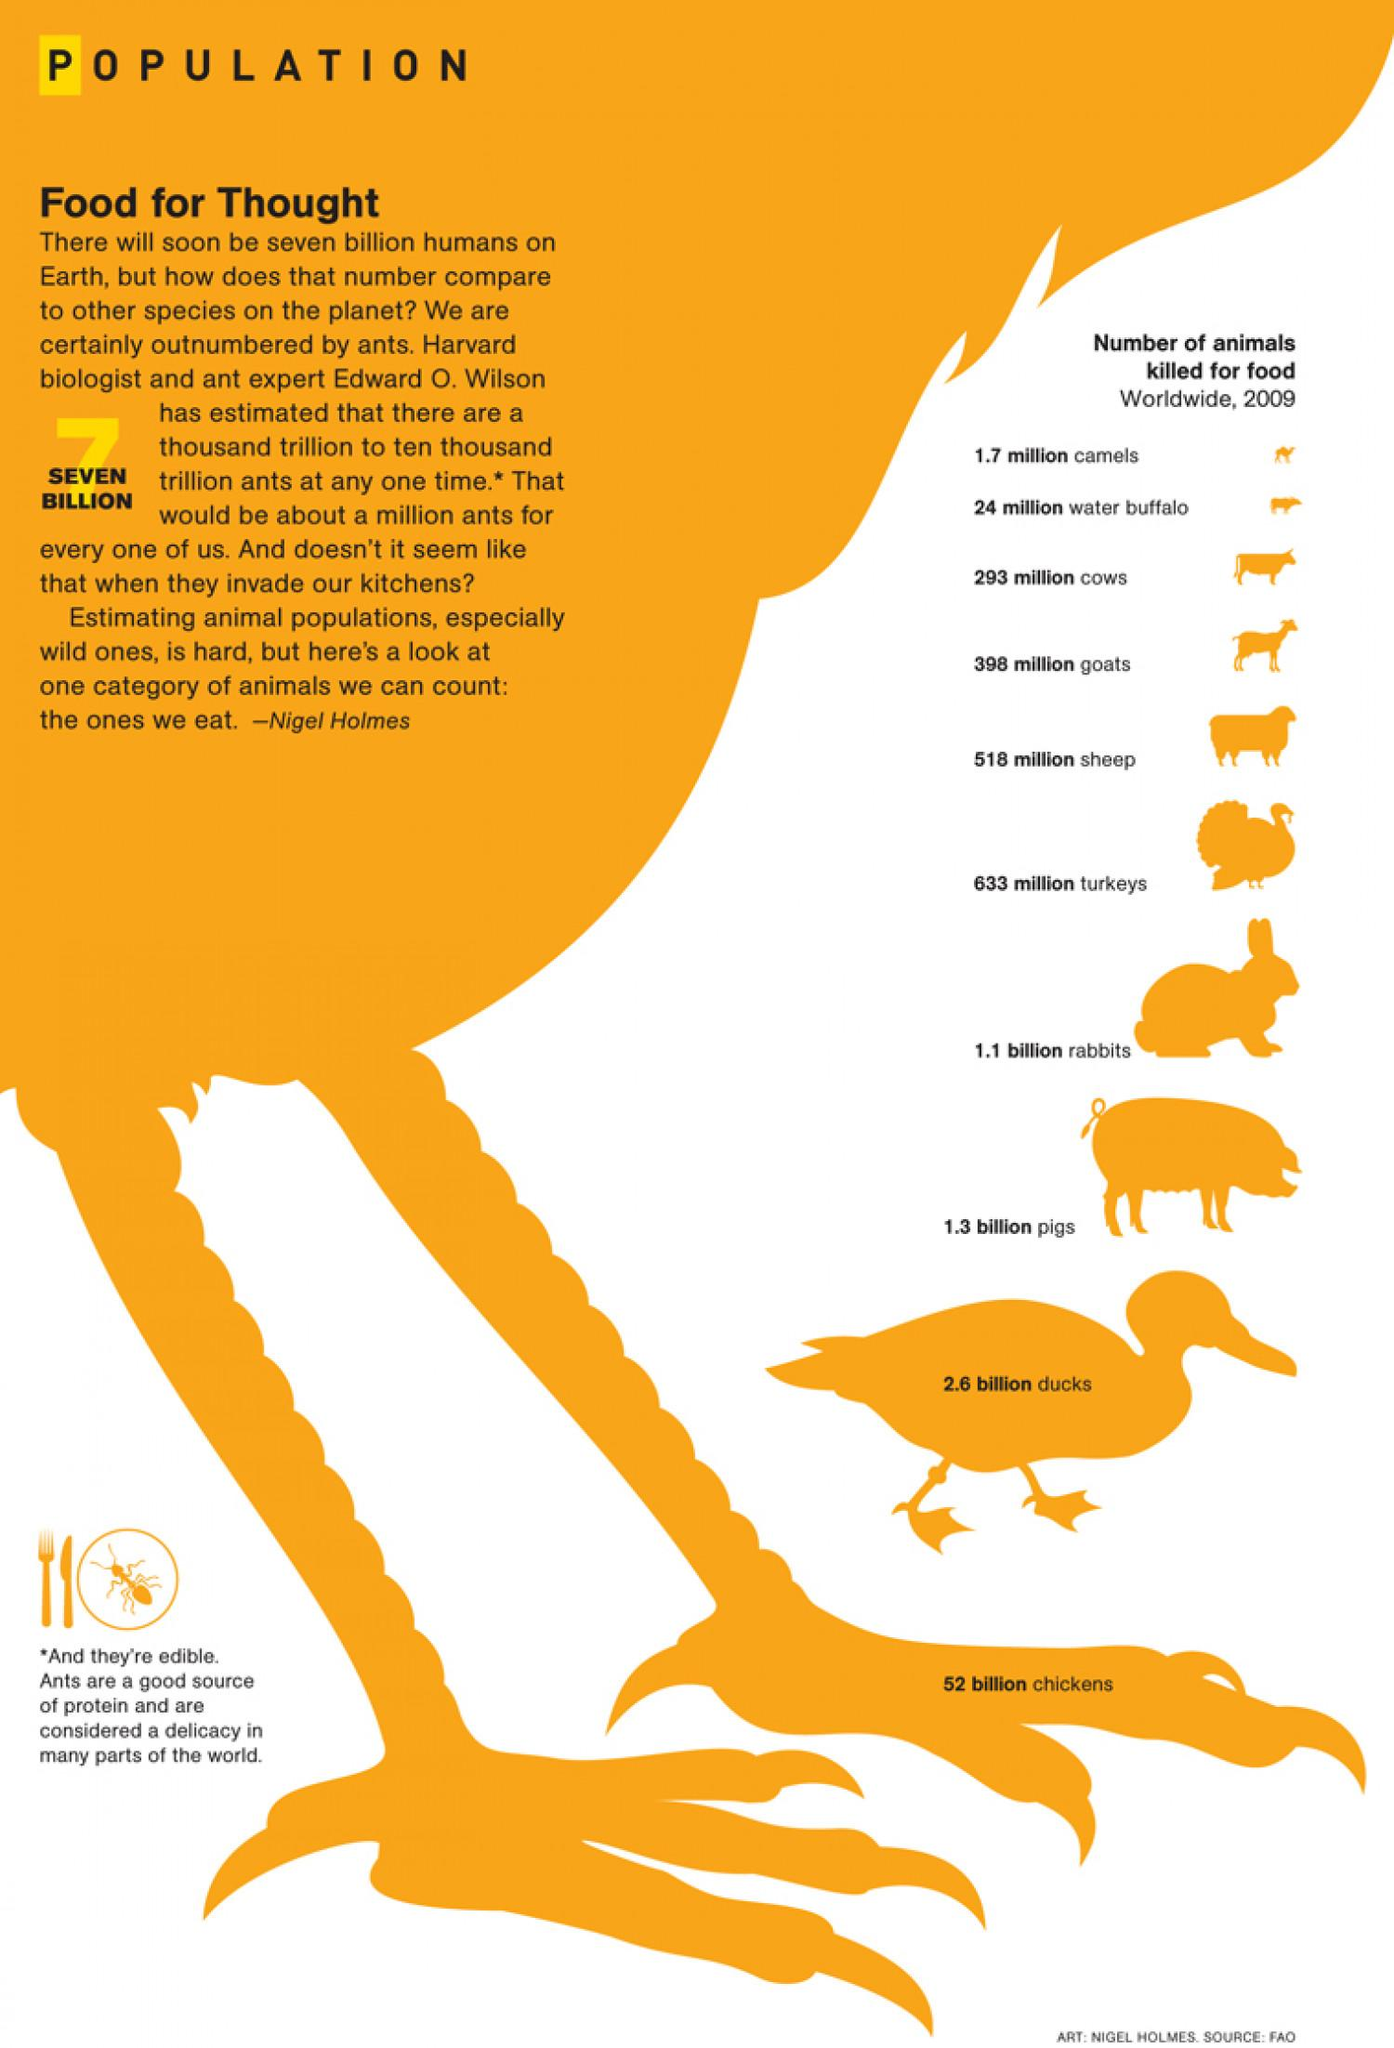Outline some significant characteristics in this image. The number of ducks and chickens killed for food is approximately 49.4 billion. Rabbits have been killed more for food than goats. The infographic provides information on the number of animals, which is 10. Cows have been killed less for food than water buffalo. The number of pigs and turkeys killed for food in millions is 667. 